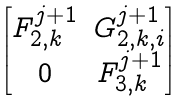<formula> <loc_0><loc_0><loc_500><loc_500>\begin{bmatrix} F _ { 2 , k } ^ { j + 1 } & G _ { 2 , k , i } ^ { j + 1 } \\ 0 & F _ { 3 , k } ^ { j + 1 } \end{bmatrix}</formula> 